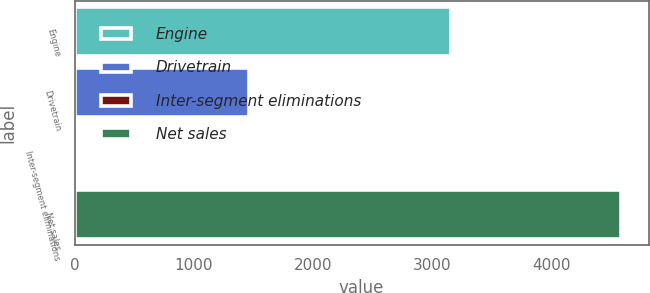<chart> <loc_0><loc_0><loc_500><loc_500><bar_chart><fcel>Engine<fcel>Drivetrain<fcel>Inter-segment eliminations<fcel>Net sales<nl><fcel>3154.9<fcel>1461.4<fcel>30.9<fcel>4585.4<nl></chart> 